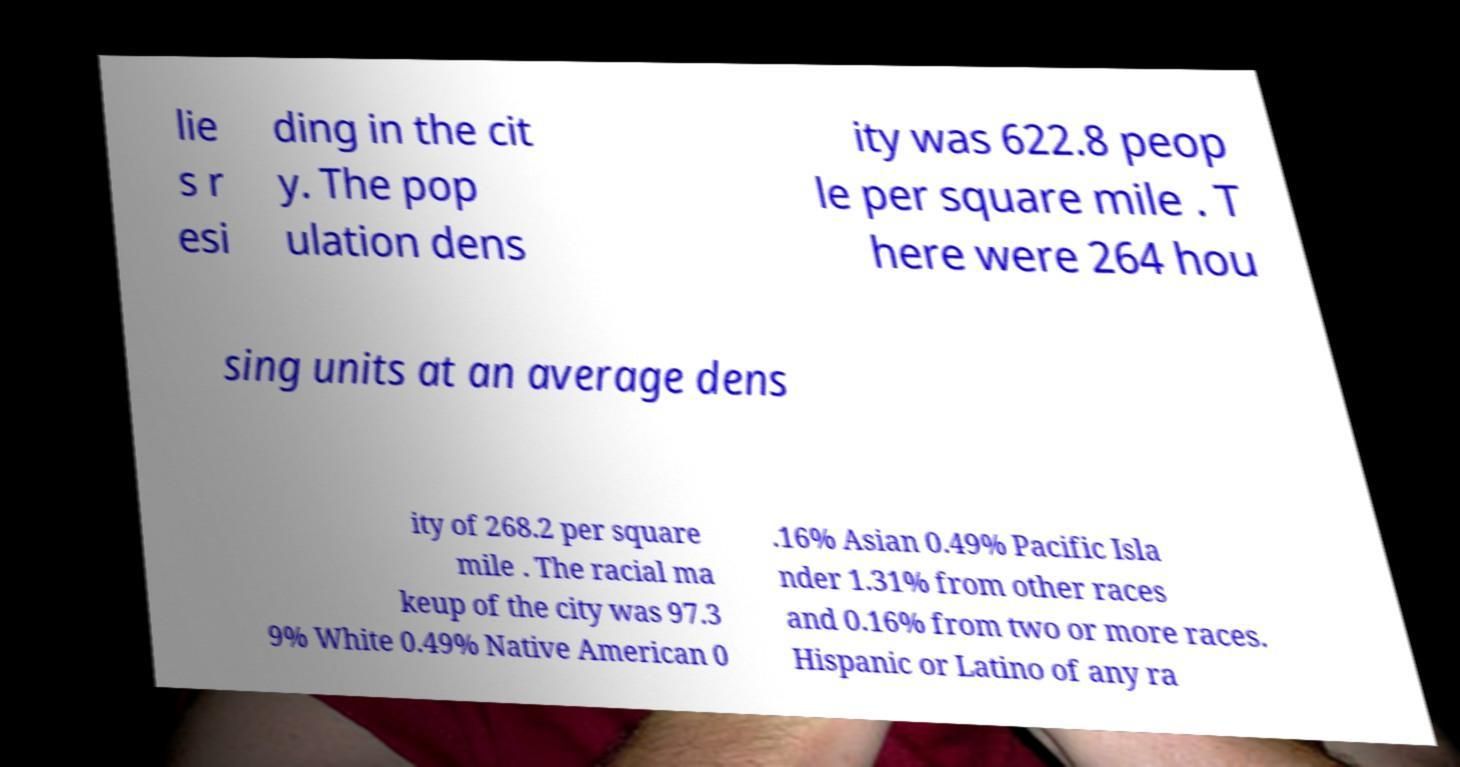Could you assist in decoding the text presented in this image and type it out clearly? lie s r esi ding in the cit y. The pop ulation dens ity was 622.8 peop le per square mile . T here were 264 hou sing units at an average dens ity of 268.2 per square mile . The racial ma keup of the city was 97.3 9% White 0.49% Native American 0 .16% Asian 0.49% Pacific Isla nder 1.31% from other races and 0.16% from two or more races. Hispanic or Latino of any ra 